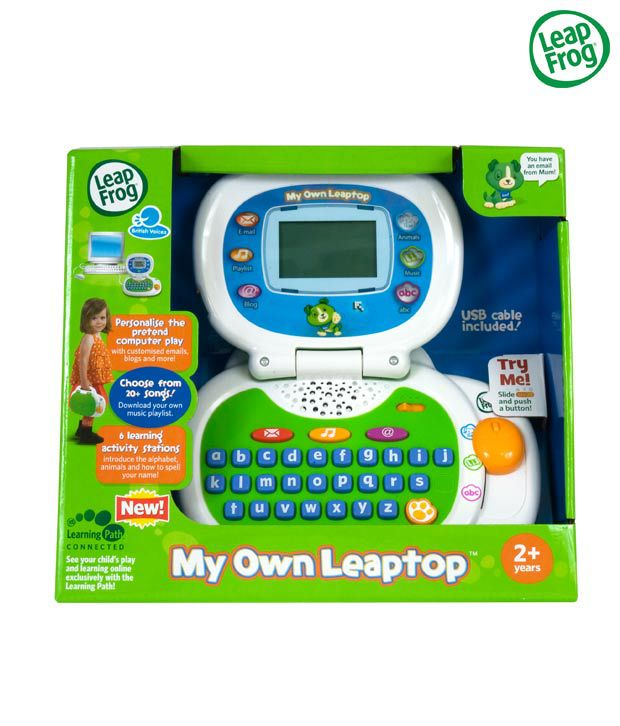What educational games might be accessible through the USB cable on this toy? Connection via USB cable could allow access to a variety of educational games that teach basics like alphabets, number counting, spelling, and simple mathematics. The games could also introduce children to music and art basics, making learning fun and interactive. Can these games be updated or expanded over time? Absolutely! The beauty of USB connectivity is that it allows the toy’s library of games to be updated or expanded as new content becomes available. Parents can download additional games and educational activities as their child's interests and learning needs evolve. 